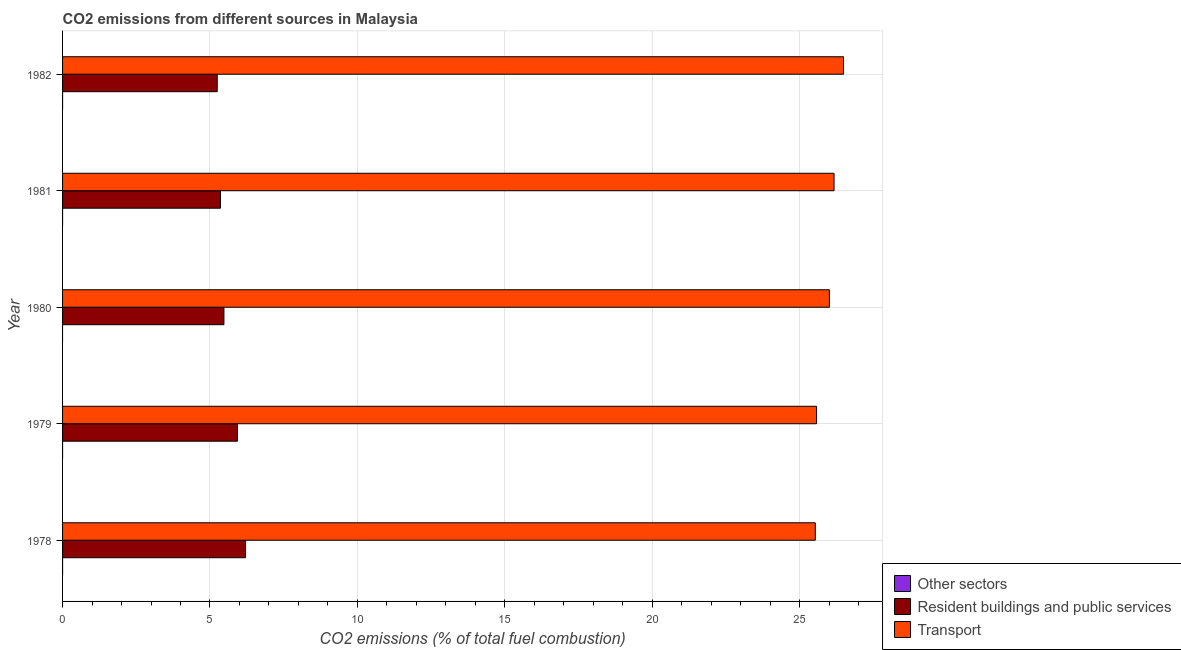How many different coloured bars are there?
Provide a succinct answer. 3. How many groups of bars are there?
Make the answer very short. 5. Are the number of bars on each tick of the Y-axis equal?
Give a very brief answer. No. How many bars are there on the 4th tick from the bottom?
Give a very brief answer. 2. What is the label of the 4th group of bars from the top?
Offer a very short reply. 1979. What is the percentage of co2 emissions from resident buildings and public services in 1980?
Provide a short and direct response. 5.47. Across all years, what is the maximum percentage of co2 emissions from transport?
Your answer should be compact. 26.49. Across all years, what is the minimum percentage of co2 emissions from resident buildings and public services?
Your response must be concise. 5.25. In which year was the percentage of co2 emissions from resident buildings and public services maximum?
Offer a very short reply. 1978. What is the total percentage of co2 emissions from resident buildings and public services in the graph?
Provide a succinct answer. 28.21. What is the difference between the percentage of co2 emissions from transport in 1978 and that in 1981?
Your answer should be very brief. -0.64. What is the difference between the percentage of co2 emissions from other sectors in 1981 and the percentage of co2 emissions from resident buildings and public services in 1982?
Your answer should be very brief. -5.25. What is the average percentage of co2 emissions from resident buildings and public services per year?
Keep it short and to the point. 5.64. In the year 1982, what is the difference between the percentage of co2 emissions from resident buildings and public services and percentage of co2 emissions from transport?
Your answer should be compact. -21.24. In how many years, is the percentage of co2 emissions from resident buildings and public services greater than 9 %?
Ensure brevity in your answer.  0. What is the ratio of the percentage of co2 emissions from resident buildings and public services in 1978 to that in 1982?
Make the answer very short. 1.18. Is the percentage of co2 emissions from transport in 1979 less than that in 1982?
Your answer should be very brief. Yes. Is the difference between the percentage of co2 emissions from resident buildings and public services in 1980 and 1981 greater than the difference between the percentage of co2 emissions from transport in 1980 and 1981?
Ensure brevity in your answer.  Yes. What is the difference between the highest and the second highest percentage of co2 emissions from resident buildings and public services?
Ensure brevity in your answer.  0.27. In how many years, is the percentage of co2 emissions from resident buildings and public services greater than the average percentage of co2 emissions from resident buildings and public services taken over all years?
Make the answer very short. 2. Is the sum of the percentage of co2 emissions from transport in 1978 and 1982 greater than the maximum percentage of co2 emissions from other sectors across all years?
Keep it short and to the point. Yes. How many years are there in the graph?
Your response must be concise. 5. What is the difference between two consecutive major ticks on the X-axis?
Offer a very short reply. 5. Are the values on the major ticks of X-axis written in scientific E-notation?
Your answer should be very brief. No. Where does the legend appear in the graph?
Ensure brevity in your answer.  Bottom right. How are the legend labels stacked?
Your response must be concise. Vertical. What is the title of the graph?
Provide a succinct answer. CO2 emissions from different sources in Malaysia. What is the label or title of the X-axis?
Offer a terse response. CO2 emissions (% of total fuel combustion). What is the label or title of the Y-axis?
Give a very brief answer. Year. What is the CO2 emissions (% of total fuel combustion) of Other sectors in 1978?
Your response must be concise. 4.201146662305081e-16. What is the CO2 emissions (% of total fuel combustion) of Resident buildings and public services in 1978?
Give a very brief answer. 6.21. What is the CO2 emissions (% of total fuel combustion) in Transport in 1978?
Offer a very short reply. 25.53. What is the CO2 emissions (% of total fuel combustion) of Other sectors in 1979?
Offer a terse response. 3.74232480210727e-16. What is the CO2 emissions (% of total fuel combustion) in Resident buildings and public services in 1979?
Your answer should be very brief. 5.93. What is the CO2 emissions (% of total fuel combustion) in Transport in 1979?
Provide a succinct answer. 25.57. What is the CO2 emissions (% of total fuel combustion) of Other sectors in 1980?
Keep it short and to the point. 0. What is the CO2 emissions (% of total fuel combustion) of Resident buildings and public services in 1980?
Ensure brevity in your answer.  5.47. What is the CO2 emissions (% of total fuel combustion) in Transport in 1980?
Ensure brevity in your answer.  26.01. What is the CO2 emissions (% of total fuel combustion) of Other sectors in 1981?
Your answer should be very brief. 0. What is the CO2 emissions (% of total fuel combustion) in Resident buildings and public services in 1981?
Provide a short and direct response. 5.36. What is the CO2 emissions (% of total fuel combustion) of Transport in 1981?
Offer a very short reply. 26.17. What is the CO2 emissions (% of total fuel combustion) in Resident buildings and public services in 1982?
Provide a short and direct response. 5.25. What is the CO2 emissions (% of total fuel combustion) in Transport in 1982?
Give a very brief answer. 26.49. Across all years, what is the maximum CO2 emissions (% of total fuel combustion) of Other sectors?
Give a very brief answer. 4.201146662305081e-16. Across all years, what is the maximum CO2 emissions (% of total fuel combustion) of Resident buildings and public services?
Give a very brief answer. 6.21. Across all years, what is the maximum CO2 emissions (% of total fuel combustion) in Transport?
Offer a very short reply. 26.49. Across all years, what is the minimum CO2 emissions (% of total fuel combustion) in Other sectors?
Give a very brief answer. 0. Across all years, what is the minimum CO2 emissions (% of total fuel combustion) in Resident buildings and public services?
Ensure brevity in your answer.  5.25. Across all years, what is the minimum CO2 emissions (% of total fuel combustion) of Transport?
Offer a terse response. 25.53. What is the total CO2 emissions (% of total fuel combustion) of Other sectors in the graph?
Give a very brief answer. 0. What is the total CO2 emissions (% of total fuel combustion) in Resident buildings and public services in the graph?
Provide a succinct answer. 28.21. What is the total CO2 emissions (% of total fuel combustion) in Transport in the graph?
Your answer should be compact. 129.76. What is the difference between the CO2 emissions (% of total fuel combustion) in Other sectors in 1978 and that in 1979?
Ensure brevity in your answer.  0. What is the difference between the CO2 emissions (% of total fuel combustion) of Resident buildings and public services in 1978 and that in 1979?
Provide a short and direct response. 0.27. What is the difference between the CO2 emissions (% of total fuel combustion) in Transport in 1978 and that in 1979?
Offer a terse response. -0.04. What is the difference between the CO2 emissions (% of total fuel combustion) of Resident buildings and public services in 1978 and that in 1980?
Your response must be concise. 0.73. What is the difference between the CO2 emissions (% of total fuel combustion) in Transport in 1978 and that in 1980?
Provide a short and direct response. -0.48. What is the difference between the CO2 emissions (% of total fuel combustion) in Resident buildings and public services in 1978 and that in 1981?
Provide a succinct answer. 0.85. What is the difference between the CO2 emissions (% of total fuel combustion) in Transport in 1978 and that in 1981?
Your answer should be compact. -0.64. What is the difference between the CO2 emissions (% of total fuel combustion) of Resident buildings and public services in 1978 and that in 1982?
Make the answer very short. 0.96. What is the difference between the CO2 emissions (% of total fuel combustion) in Transport in 1978 and that in 1982?
Ensure brevity in your answer.  -0.96. What is the difference between the CO2 emissions (% of total fuel combustion) in Resident buildings and public services in 1979 and that in 1980?
Your answer should be compact. 0.46. What is the difference between the CO2 emissions (% of total fuel combustion) of Transport in 1979 and that in 1980?
Your answer should be compact. -0.44. What is the difference between the CO2 emissions (% of total fuel combustion) of Resident buildings and public services in 1979 and that in 1981?
Keep it short and to the point. 0.58. What is the difference between the CO2 emissions (% of total fuel combustion) in Transport in 1979 and that in 1981?
Offer a very short reply. -0.59. What is the difference between the CO2 emissions (% of total fuel combustion) of Resident buildings and public services in 1979 and that in 1982?
Give a very brief answer. 0.69. What is the difference between the CO2 emissions (% of total fuel combustion) in Transport in 1979 and that in 1982?
Provide a short and direct response. -0.91. What is the difference between the CO2 emissions (% of total fuel combustion) of Resident buildings and public services in 1980 and that in 1981?
Give a very brief answer. 0.12. What is the difference between the CO2 emissions (% of total fuel combustion) in Transport in 1980 and that in 1981?
Your answer should be very brief. -0.16. What is the difference between the CO2 emissions (% of total fuel combustion) of Resident buildings and public services in 1980 and that in 1982?
Your answer should be very brief. 0.23. What is the difference between the CO2 emissions (% of total fuel combustion) in Transport in 1980 and that in 1982?
Your answer should be very brief. -0.48. What is the difference between the CO2 emissions (% of total fuel combustion) of Resident buildings and public services in 1981 and that in 1982?
Provide a short and direct response. 0.11. What is the difference between the CO2 emissions (% of total fuel combustion) of Transport in 1981 and that in 1982?
Give a very brief answer. -0.32. What is the difference between the CO2 emissions (% of total fuel combustion) of Other sectors in 1978 and the CO2 emissions (% of total fuel combustion) of Resident buildings and public services in 1979?
Keep it short and to the point. -5.93. What is the difference between the CO2 emissions (% of total fuel combustion) of Other sectors in 1978 and the CO2 emissions (% of total fuel combustion) of Transport in 1979?
Provide a short and direct response. -25.57. What is the difference between the CO2 emissions (% of total fuel combustion) of Resident buildings and public services in 1978 and the CO2 emissions (% of total fuel combustion) of Transport in 1979?
Make the answer very short. -19.37. What is the difference between the CO2 emissions (% of total fuel combustion) in Other sectors in 1978 and the CO2 emissions (% of total fuel combustion) in Resident buildings and public services in 1980?
Give a very brief answer. -5.47. What is the difference between the CO2 emissions (% of total fuel combustion) in Other sectors in 1978 and the CO2 emissions (% of total fuel combustion) in Transport in 1980?
Provide a succinct answer. -26.01. What is the difference between the CO2 emissions (% of total fuel combustion) of Resident buildings and public services in 1978 and the CO2 emissions (% of total fuel combustion) of Transport in 1980?
Ensure brevity in your answer.  -19.8. What is the difference between the CO2 emissions (% of total fuel combustion) of Other sectors in 1978 and the CO2 emissions (% of total fuel combustion) of Resident buildings and public services in 1981?
Provide a succinct answer. -5.36. What is the difference between the CO2 emissions (% of total fuel combustion) of Other sectors in 1978 and the CO2 emissions (% of total fuel combustion) of Transport in 1981?
Provide a succinct answer. -26.17. What is the difference between the CO2 emissions (% of total fuel combustion) of Resident buildings and public services in 1978 and the CO2 emissions (% of total fuel combustion) of Transport in 1981?
Offer a very short reply. -19.96. What is the difference between the CO2 emissions (% of total fuel combustion) in Other sectors in 1978 and the CO2 emissions (% of total fuel combustion) in Resident buildings and public services in 1982?
Offer a very short reply. -5.25. What is the difference between the CO2 emissions (% of total fuel combustion) in Other sectors in 1978 and the CO2 emissions (% of total fuel combustion) in Transport in 1982?
Offer a terse response. -26.49. What is the difference between the CO2 emissions (% of total fuel combustion) in Resident buildings and public services in 1978 and the CO2 emissions (% of total fuel combustion) in Transport in 1982?
Provide a short and direct response. -20.28. What is the difference between the CO2 emissions (% of total fuel combustion) in Other sectors in 1979 and the CO2 emissions (% of total fuel combustion) in Resident buildings and public services in 1980?
Make the answer very short. -5.47. What is the difference between the CO2 emissions (% of total fuel combustion) of Other sectors in 1979 and the CO2 emissions (% of total fuel combustion) of Transport in 1980?
Offer a terse response. -26.01. What is the difference between the CO2 emissions (% of total fuel combustion) of Resident buildings and public services in 1979 and the CO2 emissions (% of total fuel combustion) of Transport in 1980?
Your answer should be compact. -20.08. What is the difference between the CO2 emissions (% of total fuel combustion) in Other sectors in 1979 and the CO2 emissions (% of total fuel combustion) in Resident buildings and public services in 1981?
Offer a terse response. -5.36. What is the difference between the CO2 emissions (% of total fuel combustion) in Other sectors in 1979 and the CO2 emissions (% of total fuel combustion) in Transport in 1981?
Your answer should be compact. -26.17. What is the difference between the CO2 emissions (% of total fuel combustion) in Resident buildings and public services in 1979 and the CO2 emissions (% of total fuel combustion) in Transport in 1981?
Make the answer very short. -20.23. What is the difference between the CO2 emissions (% of total fuel combustion) of Other sectors in 1979 and the CO2 emissions (% of total fuel combustion) of Resident buildings and public services in 1982?
Your response must be concise. -5.25. What is the difference between the CO2 emissions (% of total fuel combustion) of Other sectors in 1979 and the CO2 emissions (% of total fuel combustion) of Transport in 1982?
Give a very brief answer. -26.49. What is the difference between the CO2 emissions (% of total fuel combustion) in Resident buildings and public services in 1979 and the CO2 emissions (% of total fuel combustion) in Transport in 1982?
Provide a short and direct response. -20.55. What is the difference between the CO2 emissions (% of total fuel combustion) of Resident buildings and public services in 1980 and the CO2 emissions (% of total fuel combustion) of Transport in 1981?
Provide a short and direct response. -20.69. What is the difference between the CO2 emissions (% of total fuel combustion) in Resident buildings and public services in 1980 and the CO2 emissions (% of total fuel combustion) in Transport in 1982?
Give a very brief answer. -21.01. What is the difference between the CO2 emissions (% of total fuel combustion) of Resident buildings and public services in 1981 and the CO2 emissions (% of total fuel combustion) of Transport in 1982?
Ensure brevity in your answer.  -21.13. What is the average CO2 emissions (% of total fuel combustion) in Resident buildings and public services per year?
Provide a short and direct response. 5.64. What is the average CO2 emissions (% of total fuel combustion) in Transport per year?
Offer a terse response. 25.95. In the year 1978, what is the difference between the CO2 emissions (% of total fuel combustion) of Other sectors and CO2 emissions (% of total fuel combustion) of Resident buildings and public services?
Your answer should be very brief. -6.21. In the year 1978, what is the difference between the CO2 emissions (% of total fuel combustion) in Other sectors and CO2 emissions (% of total fuel combustion) in Transport?
Provide a succinct answer. -25.53. In the year 1978, what is the difference between the CO2 emissions (% of total fuel combustion) in Resident buildings and public services and CO2 emissions (% of total fuel combustion) in Transport?
Make the answer very short. -19.32. In the year 1979, what is the difference between the CO2 emissions (% of total fuel combustion) of Other sectors and CO2 emissions (% of total fuel combustion) of Resident buildings and public services?
Give a very brief answer. -5.93. In the year 1979, what is the difference between the CO2 emissions (% of total fuel combustion) in Other sectors and CO2 emissions (% of total fuel combustion) in Transport?
Offer a terse response. -25.57. In the year 1979, what is the difference between the CO2 emissions (% of total fuel combustion) of Resident buildings and public services and CO2 emissions (% of total fuel combustion) of Transport?
Your answer should be compact. -19.64. In the year 1980, what is the difference between the CO2 emissions (% of total fuel combustion) in Resident buildings and public services and CO2 emissions (% of total fuel combustion) in Transport?
Your response must be concise. -20.54. In the year 1981, what is the difference between the CO2 emissions (% of total fuel combustion) of Resident buildings and public services and CO2 emissions (% of total fuel combustion) of Transport?
Give a very brief answer. -20.81. In the year 1982, what is the difference between the CO2 emissions (% of total fuel combustion) in Resident buildings and public services and CO2 emissions (% of total fuel combustion) in Transport?
Provide a succinct answer. -21.24. What is the ratio of the CO2 emissions (% of total fuel combustion) in Other sectors in 1978 to that in 1979?
Keep it short and to the point. 1.12. What is the ratio of the CO2 emissions (% of total fuel combustion) of Resident buildings and public services in 1978 to that in 1979?
Provide a succinct answer. 1.05. What is the ratio of the CO2 emissions (% of total fuel combustion) in Resident buildings and public services in 1978 to that in 1980?
Ensure brevity in your answer.  1.13. What is the ratio of the CO2 emissions (% of total fuel combustion) in Transport in 1978 to that in 1980?
Your response must be concise. 0.98. What is the ratio of the CO2 emissions (% of total fuel combustion) of Resident buildings and public services in 1978 to that in 1981?
Your answer should be compact. 1.16. What is the ratio of the CO2 emissions (% of total fuel combustion) in Transport in 1978 to that in 1981?
Provide a succinct answer. 0.98. What is the ratio of the CO2 emissions (% of total fuel combustion) of Resident buildings and public services in 1978 to that in 1982?
Give a very brief answer. 1.18. What is the ratio of the CO2 emissions (% of total fuel combustion) in Transport in 1978 to that in 1982?
Give a very brief answer. 0.96. What is the ratio of the CO2 emissions (% of total fuel combustion) in Resident buildings and public services in 1979 to that in 1980?
Provide a short and direct response. 1.08. What is the ratio of the CO2 emissions (% of total fuel combustion) in Transport in 1979 to that in 1980?
Provide a succinct answer. 0.98. What is the ratio of the CO2 emissions (% of total fuel combustion) in Resident buildings and public services in 1979 to that in 1981?
Give a very brief answer. 1.11. What is the ratio of the CO2 emissions (% of total fuel combustion) of Transport in 1979 to that in 1981?
Your answer should be very brief. 0.98. What is the ratio of the CO2 emissions (% of total fuel combustion) in Resident buildings and public services in 1979 to that in 1982?
Your response must be concise. 1.13. What is the ratio of the CO2 emissions (% of total fuel combustion) of Transport in 1979 to that in 1982?
Keep it short and to the point. 0.97. What is the ratio of the CO2 emissions (% of total fuel combustion) of Resident buildings and public services in 1980 to that in 1981?
Your answer should be very brief. 1.02. What is the ratio of the CO2 emissions (% of total fuel combustion) in Resident buildings and public services in 1980 to that in 1982?
Make the answer very short. 1.04. What is the ratio of the CO2 emissions (% of total fuel combustion) in Resident buildings and public services in 1981 to that in 1982?
Ensure brevity in your answer.  1.02. What is the ratio of the CO2 emissions (% of total fuel combustion) of Transport in 1981 to that in 1982?
Ensure brevity in your answer.  0.99. What is the difference between the highest and the second highest CO2 emissions (% of total fuel combustion) of Resident buildings and public services?
Give a very brief answer. 0.27. What is the difference between the highest and the second highest CO2 emissions (% of total fuel combustion) of Transport?
Make the answer very short. 0.32. What is the difference between the highest and the lowest CO2 emissions (% of total fuel combustion) in Resident buildings and public services?
Your response must be concise. 0.96. What is the difference between the highest and the lowest CO2 emissions (% of total fuel combustion) of Transport?
Your response must be concise. 0.96. 